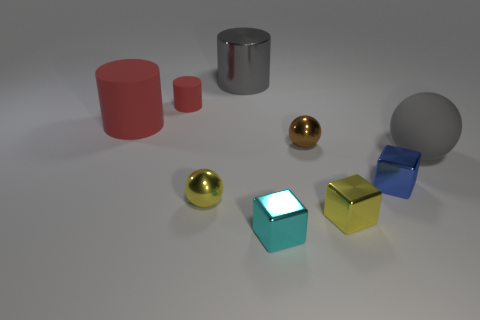What number of objects are small brown metal balls or small shiny things?
Your answer should be very brief. 5. What material is the small yellow thing to the right of the ball that is in front of the tiny blue block?
Make the answer very short. Metal. How many small blue metal objects have the same shape as the brown shiny thing?
Make the answer very short. 0. Is there a big shiny object that has the same color as the small matte object?
Give a very brief answer. No. How many things are rubber things that are on the left side of the large matte sphere or small yellow metal blocks left of the gray matte object?
Your response must be concise. 3. There is a shiny cylinder on the left side of the tiny brown metallic thing; is there a tiny cyan cube in front of it?
Provide a short and direct response. Yes. There is a brown shiny thing that is the same size as the blue metal thing; what shape is it?
Provide a succinct answer. Sphere. How many objects are matte things that are right of the blue metallic thing or tiny blue rubber balls?
Offer a terse response. 1. What number of other objects are the same material as the tiny yellow ball?
Give a very brief answer. 5. The big matte thing that is the same color as the tiny matte thing is what shape?
Provide a short and direct response. Cylinder. 